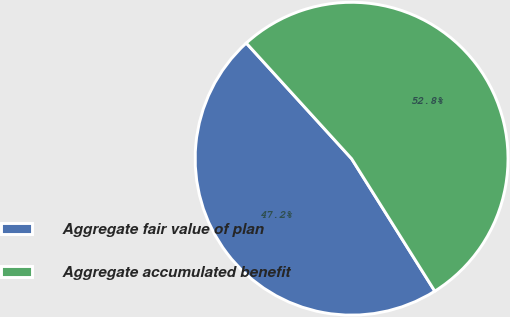Convert chart. <chart><loc_0><loc_0><loc_500><loc_500><pie_chart><fcel>Aggregate fair value of plan<fcel>Aggregate accumulated benefit<nl><fcel>47.17%<fcel>52.83%<nl></chart> 